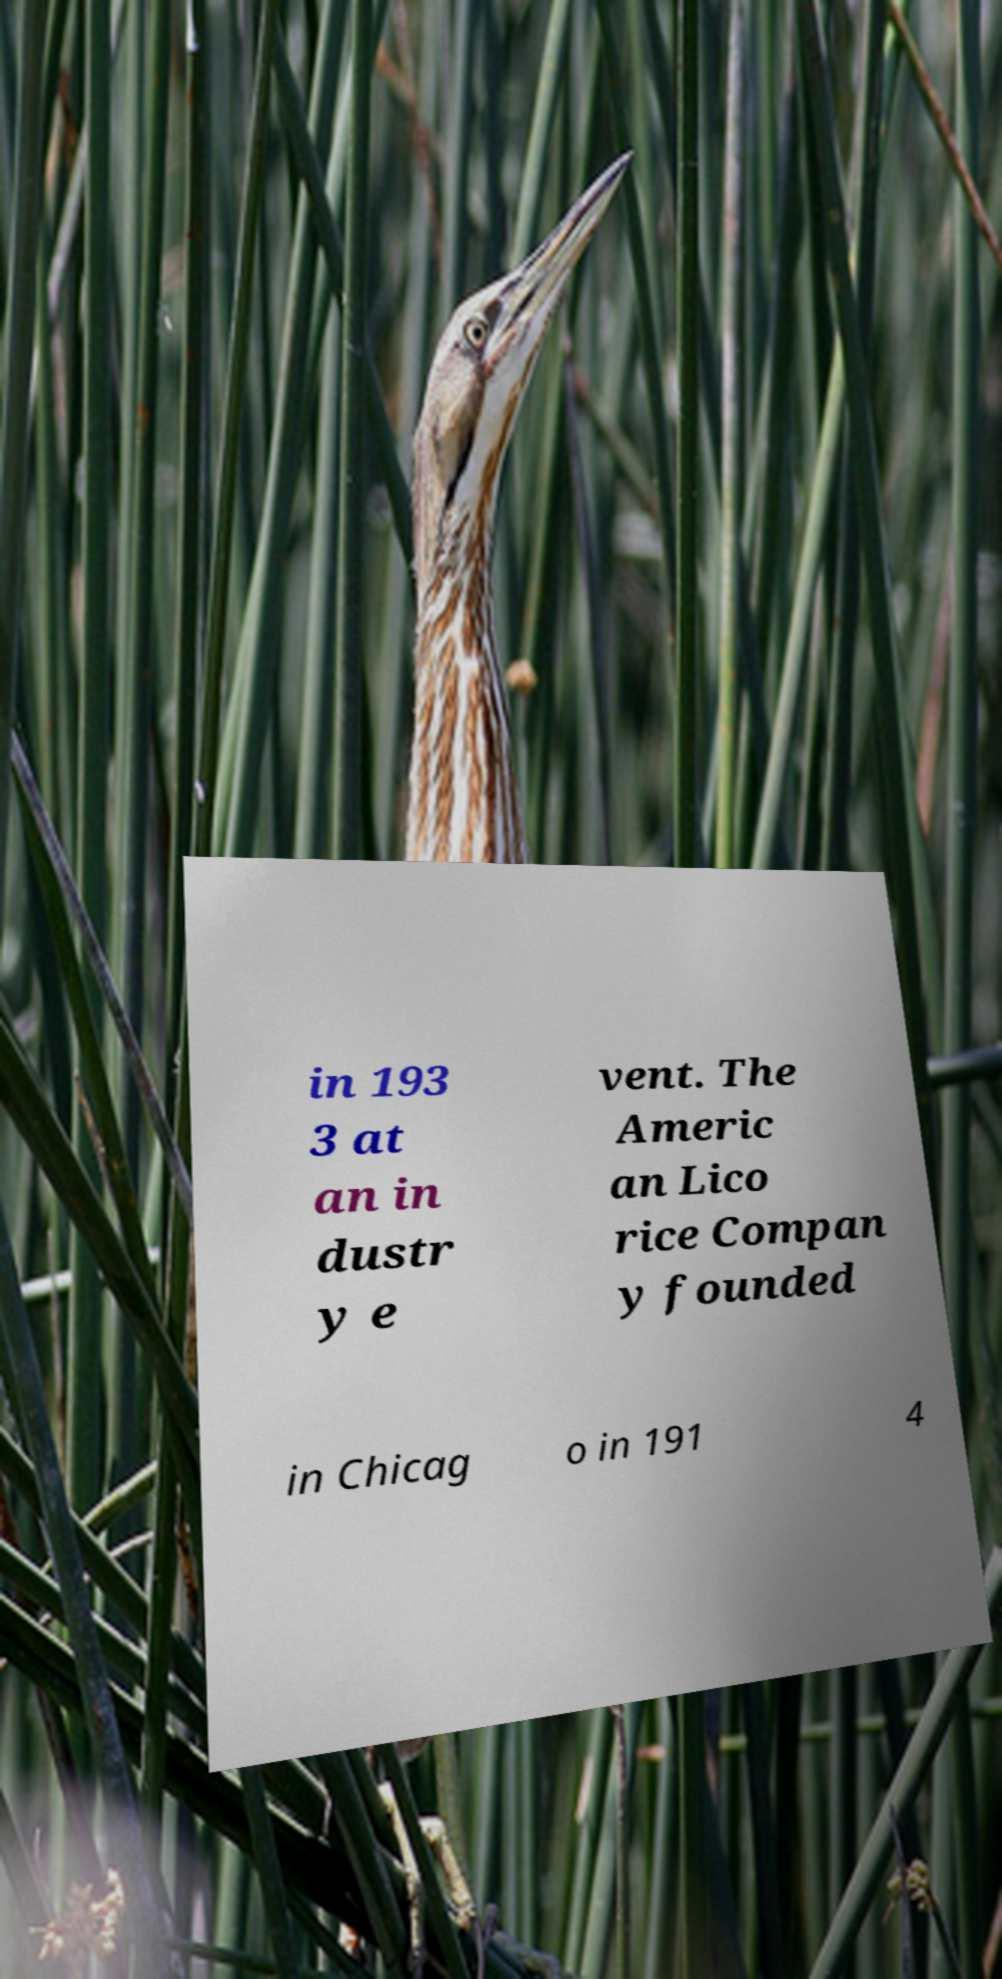There's text embedded in this image that I need extracted. Can you transcribe it verbatim? in 193 3 at an in dustr y e vent. The Americ an Lico rice Compan y founded in Chicag o in 191 4 